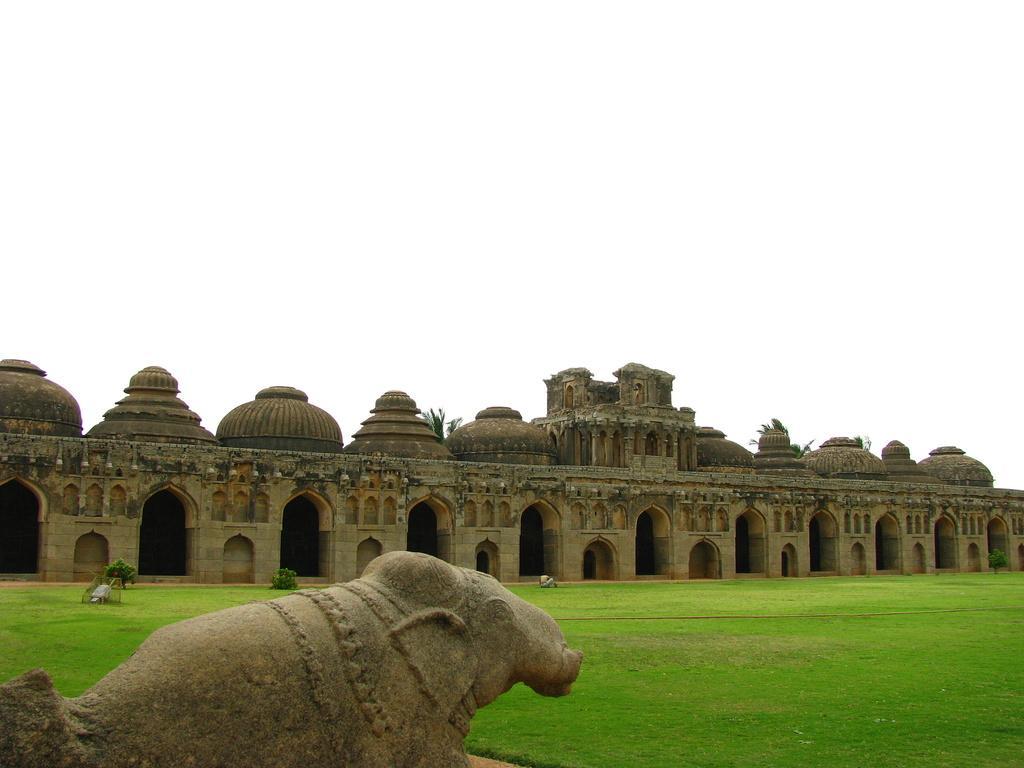Can you describe this image briefly? In this image in front there is an elephant statue. At the bottom of the image there is grass on the surface. There are plants. In the background of the image there is an architectural structure and there is sky. 